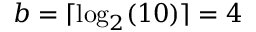Convert formula to latex. <formula><loc_0><loc_0><loc_500><loc_500>b = \lceil \log _ { 2 } ( 1 0 ) \rceil = 4</formula> 